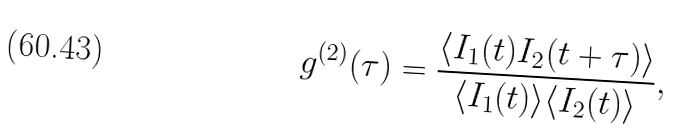<formula> <loc_0><loc_0><loc_500><loc_500>g ^ { ( 2 ) } ( \tau ) = \frac { \langle I _ { 1 } ( t ) I _ { 2 } ( t + \tau ) \rangle } { \langle I _ { 1 } ( t ) \rangle \langle I _ { 2 } ( t ) \rangle } ,</formula> 